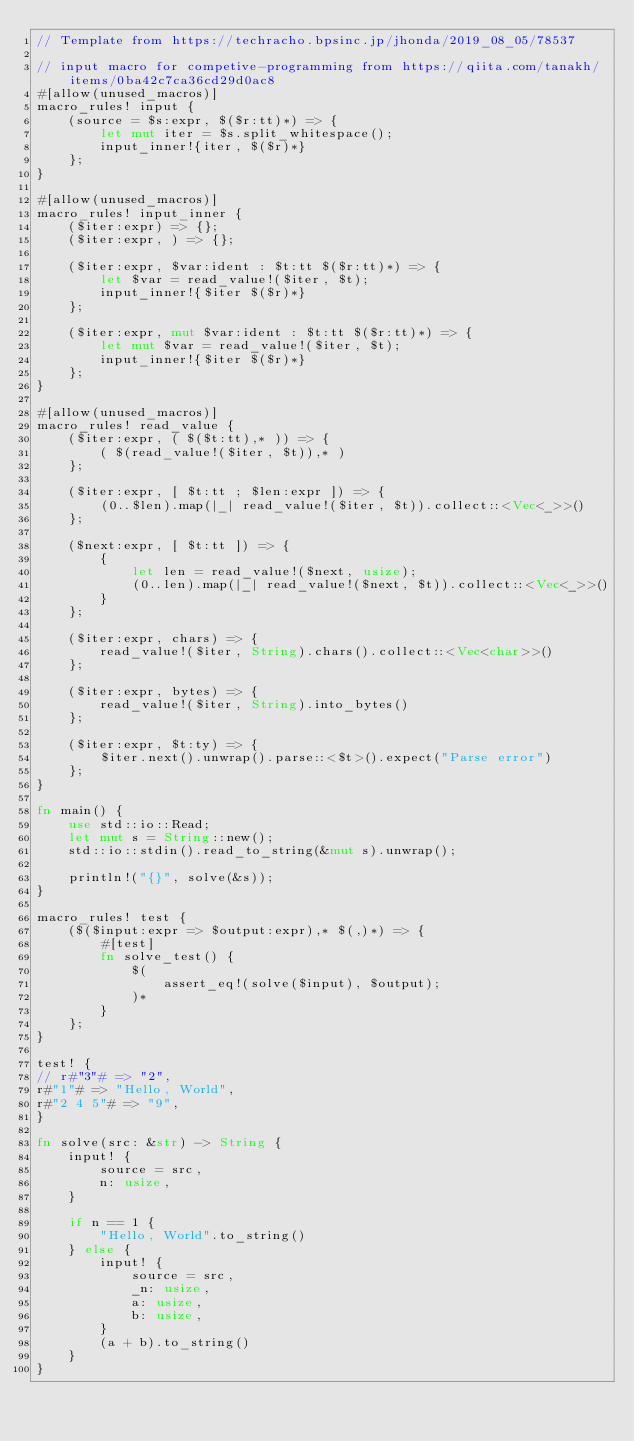<code> <loc_0><loc_0><loc_500><loc_500><_Rust_>// Template from https://techracho.bpsinc.jp/jhonda/2019_08_05/78537

// input macro for competive-programming from https://qiita.com/tanakh/items/0ba42c7ca36cd29d0ac8
#[allow(unused_macros)]
macro_rules! input {
    (source = $s:expr, $($r:tt)*) => {
        let mut iter = $s.split_whitespace();
        input_inner!{iter, $($r)*}
    };
}

#[allow(unused_macros)]
macro_rules! input_inner {
    ($iter:expr) => {};
    ($iter:expr, ) => {};

    ($iter:expr, $var:ident : $t:tt $($r:tt)*) => {
        let $var = read_value!($iter, $t);
        input_inner!{$iter $($r)*}
    };

    ($iter:expr, mut $var:ident : $t:tt $($r:tt)*) => {
        let mut $var = read_value!($iter, $t);
        input_inner!{$iter $($r)*}
    };
}

#[allow(unused_macros)]
macro_rules! read_value {
    ($iter:expr, ( $($t:tt),* )) => {
        ( $(read_value!($iter, $t)),* )
    };

    ($iter:expr, [ $t:tt ; $len:expr ]) => {
        (0..$len).map(|_| read_value!($iter, $t)).collect::<Vec<_>>()
    };

    ($next:expr, [ $t:tt ]) => {
        {
            let len = read_value!($next, usize);
            (0..len).map(|_| read_value!($next, $t)).collect::<Vec<_>>()
        }
    };

    ($iter:expr, chars) => {
        read_value!($iter, String).chars().collect::<Vec<char>>()
    };

    ($iter:expr, bytes) => {
        read_value!($iter, String).into_bytes()
    };

    ($iter:expr, $t:ty) => {
        $iter.next().unwrap().parse::<$t>().expect("Parse error")
    };
}

fn main() {
    use std::io::Read;
    let mut s = String::new();
    std::io::stdin().read_to_string(&mut s).unwrap();

    println!("{}", solve(&s));
}

macro_rules! test {
    ($($input:expr => $output:expr),* $(,)*) => {
        #[test]
        fn solve_test() {
            $(
                assert_eq!(solve($input), $output);
            )*
        }
    };
}

test! {
// r#"3"# => "2",
r#"1"# => "Hello, World",
r#"2 4 5"# => "9",
}

fn solve(src: &str) -> String {
    input! {
        source = src,
        n: usize,
    }

    if n == 1 {
        "Hello, World".to_string()
    } else {
        input! {
            source = src,
            _n: usize,
            a: usize,
            b: usize,
        }
        (a + b).to_string()
    }
}</code> 